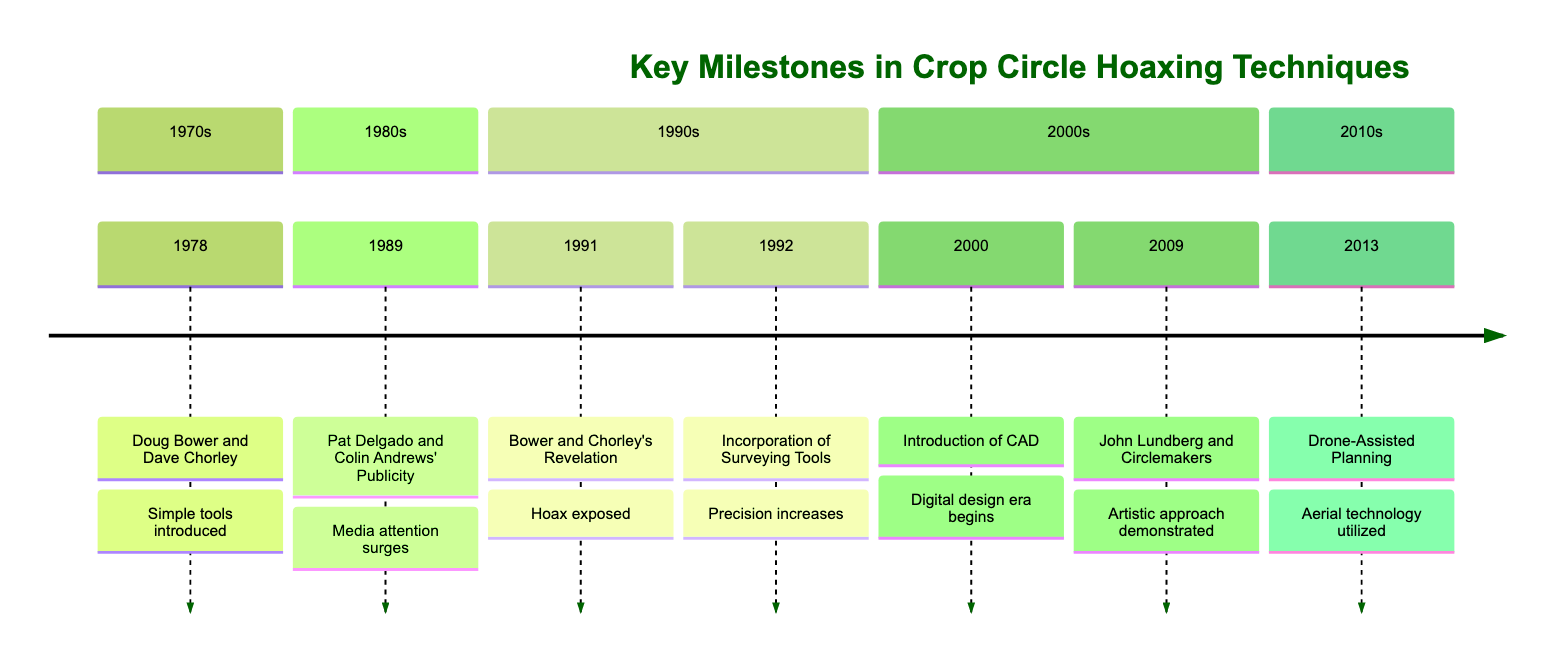What year did Doug Bower and Dave Chorley initiate the modern crop circle hoaxing movement? The diagram indicates that the year is 1978, which is directly stated in the section about Doug Bower and Dave Chorley.
Answer: 1978 How many significant milestones are listed in the timeline? By counting each entry in the timeline, there are seven notable milestones listed related to crop circle hoaxing techniques.
Answer: 7 What is the main tool introduced by Bower and Chorley in 1978? The diagram states that Bower and Chorley used "simple tools" like wooden planks, ropes, and a baseball cap fitted with a loop of wire to create crop circles.
Answer: Wooden planks In which year did hoaxers begin using surveying tools for better precision? Referring to the timeline, the use of surveying tools began in 1992 as indicated in the corresponding section.
Answer: 1992 What notable event happened in 2000 regarding crop circles? The timeline highlights that in 2000, there was the "Introduction of Computer Aided Design (CAD)," marking a shift in the methodologies used for creating crop circles.
Answer: Introduction of CAD Who led the Circlemakers collective and what year did they present their artistic approach to crop circles? The diagram specifies that John Lundberg led the Circlemakers collective and this event occurred in 2009, as stated in the relevant section.
Answer: John Lundberg What was a significant technological advancement mentioned in the timeline for creating crop circles in 2013? According to the timeline, drones were employed for capturing aerial views and planning, which represented a significant advancement in crop circle hoaxing techniques in 2013.
Answer: Drone-Assisted Planning What was the impact of the book 'Circular Evidence' published in 1989? The timeline indicates that this publication led to a surge in media attention, helping to popularize crop circles, which ultimately motivated further hoaxes as suggested in the description.
Answer: Media attention surges 